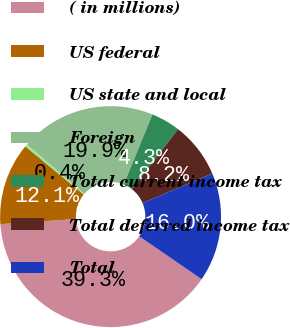Convert chart to OTSL. <chart><loc_0><loc_0><loc_500><loc_500><pie_chart><fcel>( in millions)<fcel>US federal<fcel>US state and local<fcel>Foreign<fcel>Total current income tax<fcel>Total deferred income tax<fcel>Total<nl><fcel>39.33%<fcel>12.06%<fcel>0.37%<fcel>19.85%<fcel>4.27%<fcel>8.16%<fcel>15.96%<nl></chart> 